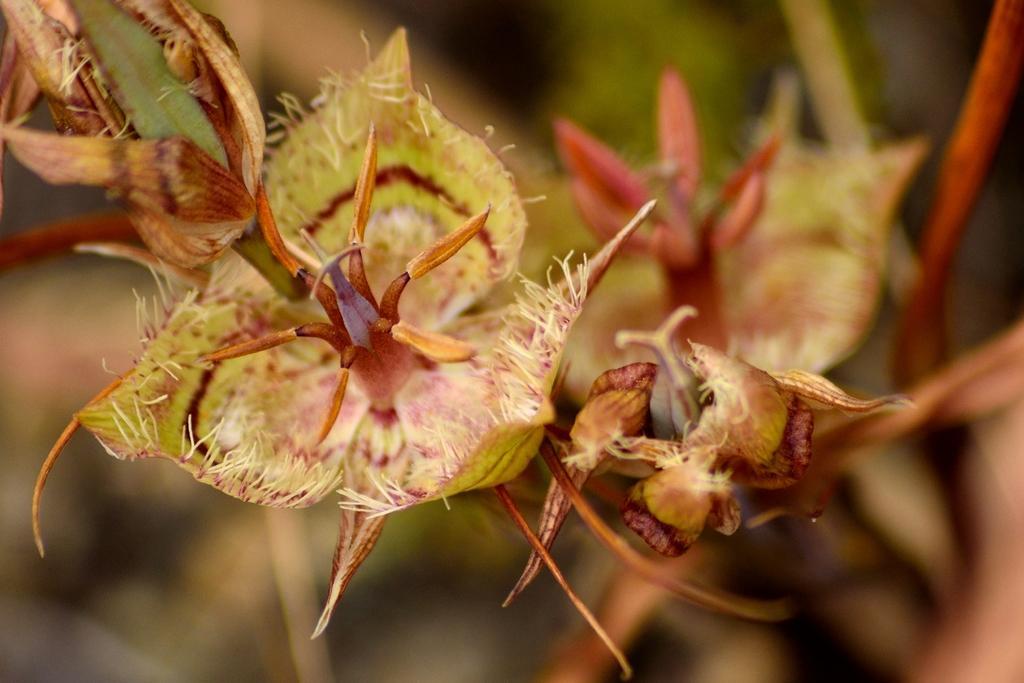Describe this image in one or two sentences. In this picture i can see many flowers and buds. In the background i can see the blur. 